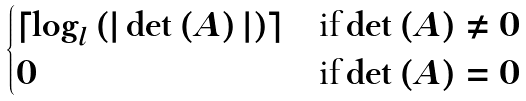Convert formula to latex. <formula><loc_0><loc_0><loc_500><loc_500>\begin{cases} \lceil \log _ { l } \left ( | \det \left ( A \right ) | \right ) \rceil & \text {if} \det \left ( A \right ) \neq 0 \\ 0 & \text {if} \det \left ( A \right ) = 0 \end{cases}</formula> 